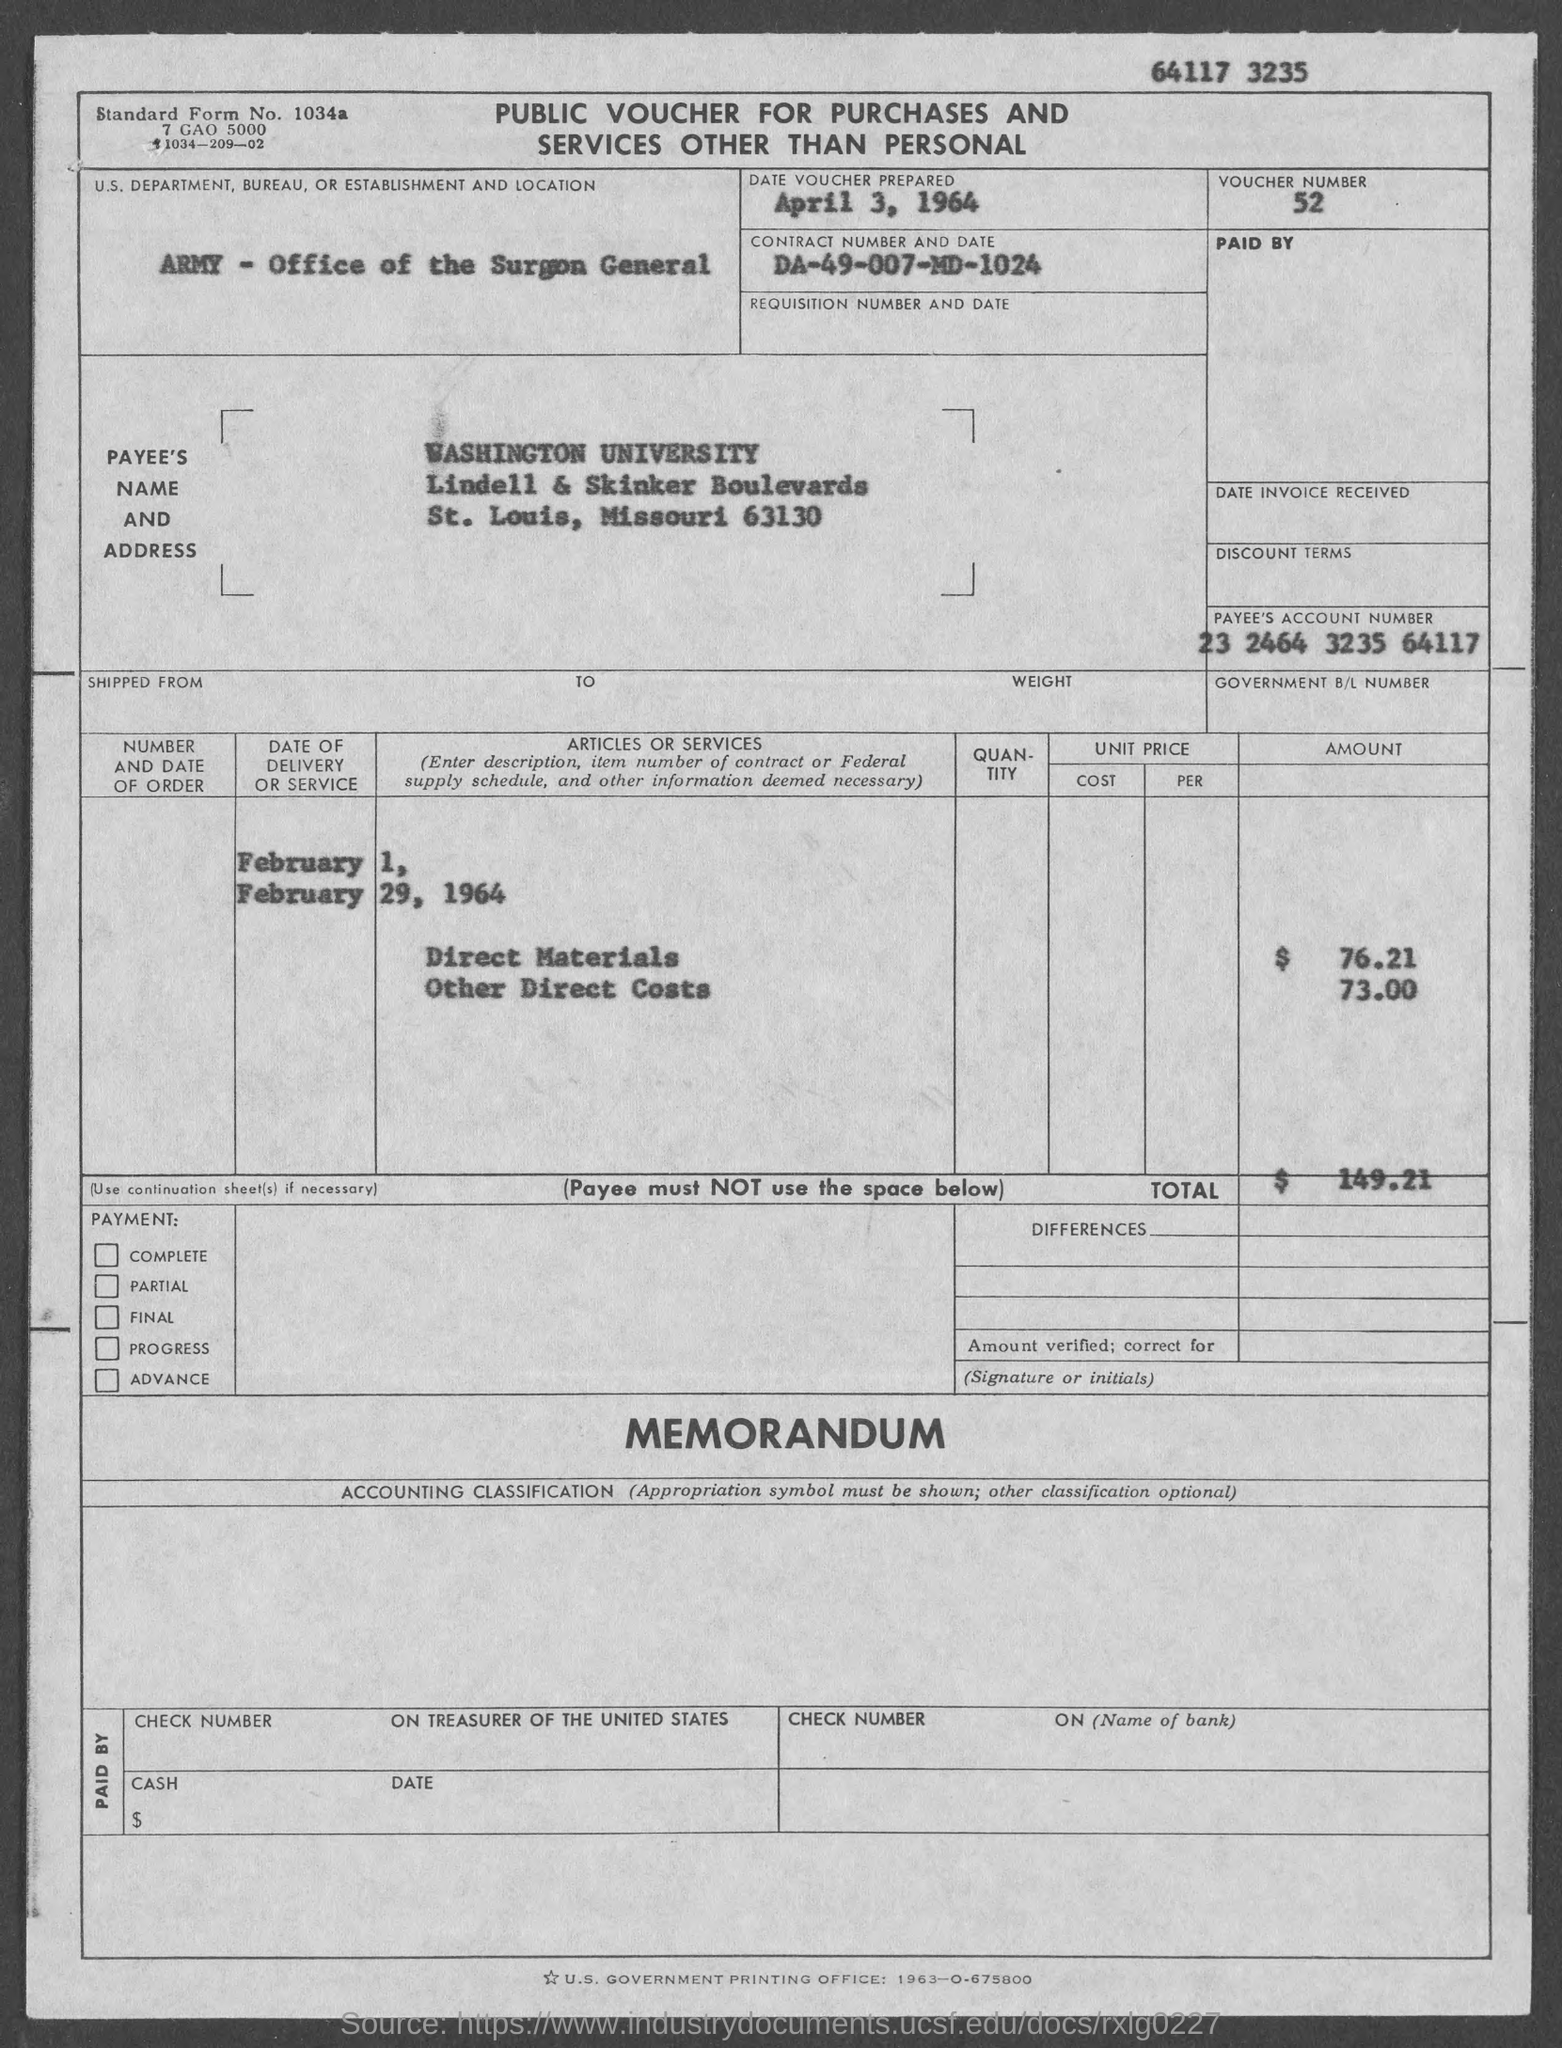Identify some key points in this picture. The payee's account number, as provided in the voucher, is 23 2464 3235 64117. On April 3, 1964, the date of the voucher was prepared. The voucher indicates that the U.S. Department, Bureau, or Establishment mentioned is the Army's Office of the Surgeon General. The voucher number mentioned in the document is 52. The total voucher amount mentioned in the document is $149.21. 